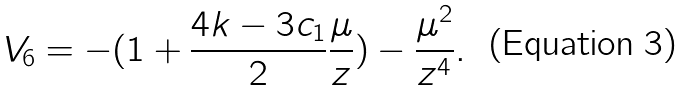<formula> <loc_0><loc_0><loc_500><loc_500>V _ { 6 } = - ( 1 + \frac { 4 k - 3 c _ { 1 } } { 2 } \frac { \mu } { z } ) - \frac { \mu ^ { 2 } } { z ^ { 4 } } .</formula> 